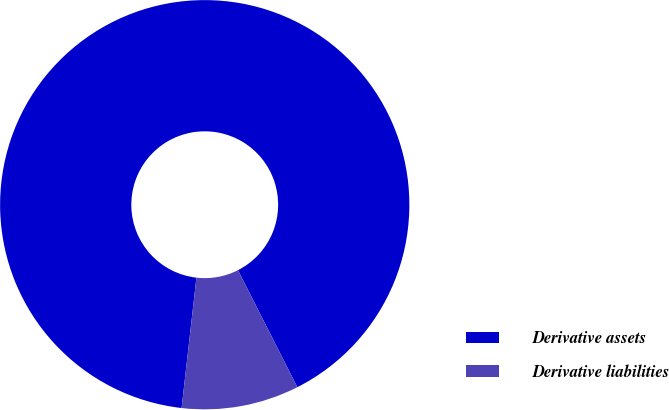<chart> <loc_0><loc_0><loc_500><loc_500><pie_chart><fcel>Derivative assets<fcel>Derivative liabilities<nl><fcel>90.72%<fcel>9.28%<nl></chart> 